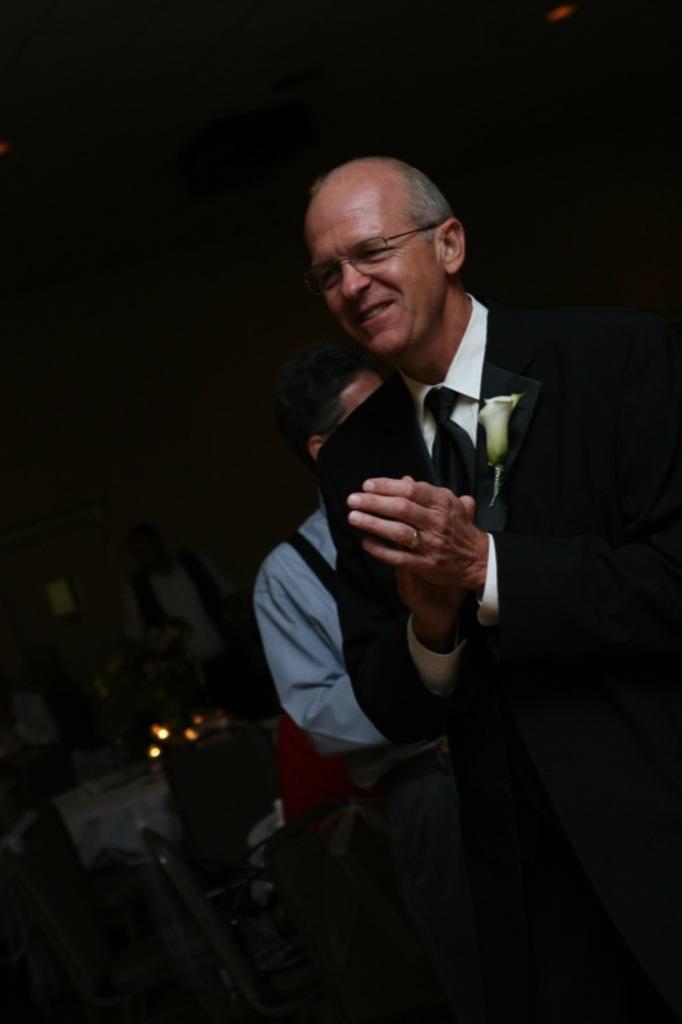How would you summarize this image in a sentence or two? In this image there is a man standing. He is clapping the hands. Behind him there are people sitting on the chairs. The background is dark. 